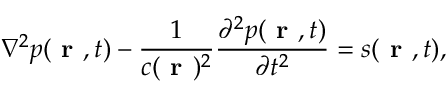<formula> <loc_0><loc_0><loc_500><loc_500>\nabla ^ { 2 } p ( r , t ) - \frac { 1 } { c ( r ) ^ { 2 } } \frac { \partial ^ { 2 } p ( r , t ) } { \partial t ^ { 2 } } = s ( r , t ) ,</formula> 